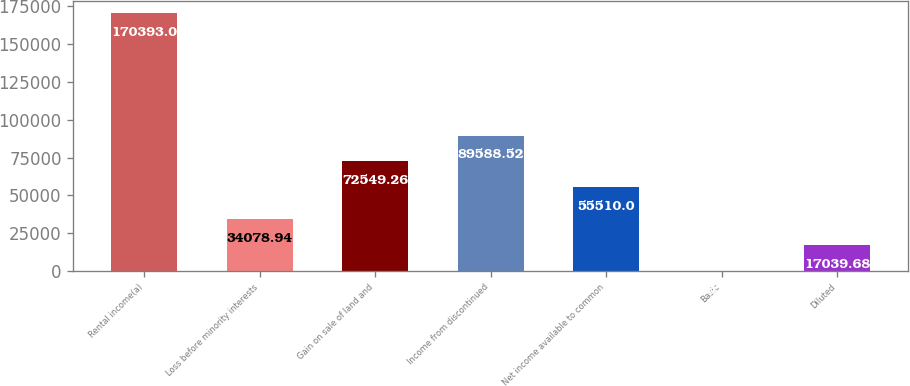Convert chart. <chart><loc_0><loc_0><loc_500><loc_500><bar_chart><fcel>Rental income(a)<fcel>Loss before minority interests<fcel>Gain on sale of land and<fcel>Income from discontinued<fcel>Net income available to common<fcel>Basic<fcel>Diluted<nl><fcel>170393<fcel>34078.9<fcel>72549.3<fcel>89588.5<fcel>55510<fcel>0.42<fcel>17039.7<nl></chart> 